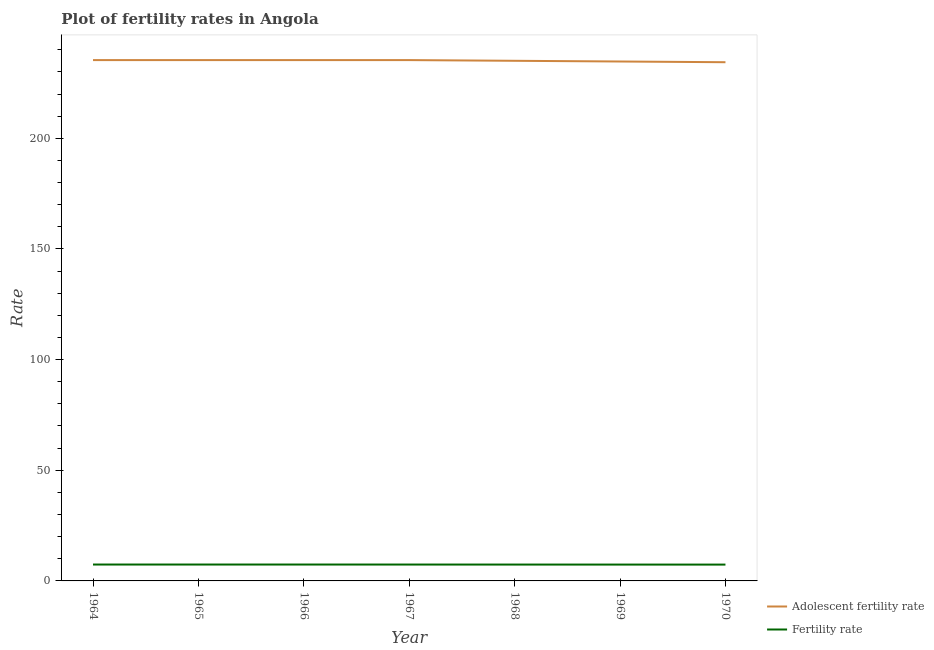Does the line corresponding to fertility rate intersect with the line corresponding to adolescent fertility rate?
Your answer should be very brief. No. Is the number of lines equal to the number of legend labels?
Your response must be concise. Yes. What is the adolescent fertility rate in 1966?
Give a very brief answer. 235.32. Across all years, what is the maximum fertility rate?
Ensure brevity in your answer.  7.41. Across all years, what is the minimum adolescent fertility rate?
Your response must be concise. 234.37. In which year was the adolescent fertility rate maximum?
Ensure brevity in your answer.  1964. What is the total fertility rate in the graph?
Make the answer very short. 51.77. What is the difference between the adolescent fertility rate in 1967 and that in 1968?
Make the answer very short. 0.32. What is the difference between the fertility rate in 1968 and the adolescent fertility rate in 1970?
Your answer should be very brief. -226.97. What is the average adolescent fertility rate per year?
Give a very brief answer. 235.05. In the year 1967, what is the difference between the adolescent fertility rate and fertility rate?
Give a very brief answer. 227.92. In how many years, is the fertility rate greater than 120?
Provide a short and direct response. 0. What is the ratio of the fertility rate in 1964 to that in 1965?
Provide a short and direct response. 1. What is the difference between the highest and the second highest fertility rate?
Make the answer very short. 0. What is the difference between the highest and the lowest fertility rate?
Ensure brevity in your answer.  0.03. Is the fertility rate strictly greater than the adolescent fertility rate over the years?
Make the answer very short. No. How many years are there in the graph?
Offer a terse response. 7. What is the difference between two consecutive major ticks on the Y-axis?
Your response must be concise. 50. Does the graph contain any zero values?
Keep it short and to the point. No. How many legend labels are there?
Your response must be concise. 2. What is the title of the graph?
Ensure brevity in your answer.  Plot of fertility rates in Angola. What is the label or title of the Y-axis?
Your response must be concise. Rate. What is the Rate in Adolescent fertility rate in 1964?
Ensure brevity in your answer.  235.32. What is the Rate of Fertility rate in 1964?
Your answer should be very brief. 7.41. What is the Rate in Adolescent fertility rate in 1965?
Offer a very short reply. 235.32. What is the Rate of Fertility rate in 1965?
Your answer should be very brief. 7.41. What is the Rate of Adolescent fertility rate in 1966?
Your answer should be very brief. 235.32. What is the Rate in Fertility rate in 1966?
Provide a succinct answer. 7.41. What is the Rate of Adolescent fertility rate in 1967?
Give a very brief answer. 235.32. What is the Rate of Fertility rate in 1967?
Offer a very short reply. 7.4. What is the Rate in Adolescent fertility rate in 1968?
Give a very brief answer. 235. What is the Rate of Fertility rate in 1968?
Offer a very short reply. 7.39. What is the Rate in Adolescent fertility rate in 1969?
Offer a terse response. 234.68. What is the Rate in Fertility rate in 1969?
Give a very brief answer. 7.38. What is the Rate of Adolescent fertility rate in 1970?
Your answer should be compact. 234.37. What is the Rate in Fertility rate in 1970?
Provide a short and direct response. 7.38. Across all years, what is the maximum Rate in Adolescent fertility rate?
Your answer should be very brief. 235.32. Across all years, what is the maximum Rate in Fertility rate?
Offer a terse response. 7.41. Across all years, what is the minimum Rate in Adolescent fertility rate?
Keep it short and to the point. 234.37. Across all years, what is the minimum Rate of Fertility rate?
Provide a succinct answer. 7.38. What is the total Rate in Adolescent fertility rate in the graph?
Provide a succinct answer. 1645.33. What is the total Rate in Fertility rate in the graph?
Make the answer very short. 51.77. What is the difference between the Rate in Adolescent fertility rate in 1964 and that in 1965?
Give a very brief answer. 0. What is the difference between the Rate in Fertility rate in 1964 and that in 1965?
Your answer should be compact. -0. What is the difference between the Rate in Fertility rate in 1964 and that in 1967?
Your answer should be compact. 0.01. What is the difference between the Rate of Adolescent fertility rate in 1964 and that in 1968?
Give a very brief answer. 0.32. What is the difference between the Rate in Fertility rate in 1964 and that in 1968?
Provide a short and direct response. 0.01. What is the difference between the Rate in Adolescent fertility rate in 1964 and that in 1969?
Your answer should be very brief. 0.64. What is the difference between the Rate of Fertility rate in 1964 and that in 1969?
Make the answer very short. 0.02. What is the difference between the Rate of Adolescent fertility rate in 1964 and that in 1970?
Your response must be concise. 0.95. What is the difference between the Rate in Fertility rate in 1964 and that in 1970?
Keep it short and to the point. 0.03. What is the difference between the Rate in Adolescent fertility rate in 1965 and that in 1966?
Make the answer very short. 0. What is the difference between the Rate in Fertility rate in 1965 and that in 1966?
Offer a very short reply. 0. What is the difference between the Rate of Adolescent fertility rate in 1965 and that in 1967?
Offer a very short reply. 0. What is the difference between the Rate in Fertility rate in 1965 and that in 1967?
Your response must be concise. 0.01. What is the difference between the Rate in Adolescent fertility rate in 1965 and that in 1968?
Ensure brevity in your answer.  0.32. What is the difference between the Rate in Fertility rate in 1965 and that in 1968?
Ensure brevity in your answer.  0.01. What is the difference between the Rate of Adolescent fertility rate in 1965 and that in 1969?
Offer a terse response. 0.64. What is the difference between the Rate of Fertility rate in 1965 and that in 1969?
Offer a terse response. 0.02. What is the difference between the Rate in Adolescent fertility rate in 1965 and that in 1970?
Your response must be concise. 0.95. What is the difference between the Rate in Fertility rate in 1965 and that in 1970?
Give a very brief answer. 0.03. What is the difference between the Rate in Fertility rate in 1966 and that in 1967?
Your response must be concise. 0.01. What is the difference between the Rate in Adolescent fertility rate in 1966 and that in 1968?
Your response must be concise. 0.32. What is the difference between the Rate of Fertility rate in 1966 and that in 1968?
Your answer should be very brief. 0.01. What is the difference between the Rate in Adolescent fertility rate in 1966 and that in 1969?
Your response must be concise. 0.64. What is the difference between the Rate in Fertility rate in 1966 and that in 1969?
Provide a succinct answer. 0.02. What is the difference between the Rate of Adolescent fertility rate in 1966 and that in 1970?
Your answer should be compact. 0.95. What is the difference between the Rate of Fertility rate in 1966 and that in 1970?
Offer a terse response. 0.03. What is the difference between the Rate in Adolescent fertility rate in 1967 and that in 1968?
Your answer should be very brief. 0.32. What is the difference between the Rate of Fertility rate in 1967 and that in 1968?
Make the answer very short. 0.01. What is the difference between the Rate of Adolescent fertility rate in 1967 and that in 1969?
Your response must be concise. 0.64. What is the difference between the Rate of Fertility rate in 1967 and that in 1969?
Keep it short and to the point. 0.02. What is the difference between the Rate of Adolescent fertility rate in 1967 and that in 1970?
Give a very brief answer. 0.95. What is the difference between the Rate of Fertility rate in 1967 and that in 1970?
Offer a terse response. 0.03. What is the difference between the Rate in Adolescent fertility rate in 1968 and that in 1969?
Offer a very short reply. 0.32. What is the difference between the Rate in Fertility rate in 1968 and that in 1969?
Give a very brief answer. 0.01. What is the difference between the Rate of Adolescent fertility rate in 1968 and that in 1970?
Your answer should be compact. 0.64. What is the difference between the Rate of Fertility rate in 1968 and that in 1970?
Provide a short and direct response. 0.02. What is the difference between the Rate of Adolescent fertility rate in 1969 and that in 1970?
Offer a terse response. 0.32. What is the difference between the Rate in Fertility rate in 1969 and that in 1970?
Provide a succinct answer. 0.01. What is the difference between the Rate in Adolescent fertility rate in 1964 and the Rate in Fertility rate in 1965?
Give a very brief answer. 227.91. What is the difference between the Rate of Adolescent fertility rate in 1964 and the Rate of Fertility rate in 1966?
Offer a very short reply. 227.91. What is the difference between the Rate in Adolescent fertility rate in 1964 and the Rate in Fertility rate in 1967?
Provide a short and direct response. 227.92. What is the difference between the Rate in Adolescent fertility rate in 1964 and the Rate in Fertility rate in 1968?
Ensure brevity in your answer.  227.93. What is the difference between the Rate in Adolescent fertility rate in 1964 and the Rate in Fertility rate in 1969?
Make the answer very short. 227.94. What is the difference between the Rate in Adolescent fertility rate in 1964 and the Rate in Fertility rate in 1970?
Offer a terse response. 227.94. What is the difference between the Rate of Adolescent fertility rate in 1965 and the Rate of Fertility rate in 1966?
Provide a succinct answer. 227.91. What is the difference between the Rate in Adolescent fertility rate in 1965 and the Rate in Fertility rate in 1967?
Offer a very short reply. 227.92. What is the difference between the Rate of Adolescent fertility rate in 1965 and the Rate of Fertility rate in 1968?
Your answer should be compact. 227.93. What is the difference between the Rate in Adolescent fertility rate in 1965 and the Rate in Fertility rate in 1969?
Your response must be concise. 227.94. What is the difference between the Rate in Adolescent fertility rate in 1965 and the Rate in Fertility rate in 1970?
Your answer should be very brief. 227.94. What is the difference between the Rate of Adolescent fertility rate in 1966 and the Rate of Fertility rate in 1967?
Ensure brevity in your answer.  227.92. What is the difference between the Rate of Adolescent fertility rate in 1966 and the Rate of Fertility rate in 1968?
Offer a very short reply. 227.93. What is the difference between the Rate of Adolescent fertility rate in 1966 and the Rate of Fertility rate in 1969?
Provide a short and direct response. 227.94. What is the difference between the Rate of Adolescent fertility rate in 1966 and the Rate of Fertility rate in 1970?
Provide a short and direct response. 227.94. What is the difference between the Rate in Adolescent fertility rate in 1967 and the Rate in Fertility rate in 1968?
Your answer should be compact. 227.93. What is the difference between the Rate in Adolescent fertility rate in 1967 and the Rate in Fertility rate in 1969?
Ensure brevity in your answer.  227.94. What is the difference between the Rate of Adolescent fertility rate in 1967 and the Rate of Fertility rate in 1970?
Your answer should be very brief. 227.94. What is the difference between the Rate of Adolescent fertility rate in 1968 and the Rate of Fertility rate in 1969?
Your answer should be compact. 227.62. What is the difference between the Rate of Adolescent fertility rate in 1968 and the Rate of Fertility rate in 1970?
Provide a succinct answer. 227.63. What is the difference between the Rate of Adolescent fertility rate in 1969 and the Rate of Fertility rate in 1970?
Your answer should be very brief. 227.31. What is the average Rate in Adolescent fertility rate per year?
Your answer should be compact. 235.05. What is the average Rate of Fertility rate per year?
Offer a terse response. 7.4. In the year 1964, what is the difference between the Rate of Adolescent fertility rate and Rate of Fertility rate?
Provide a short and direct response. 227.91. In the year 1965, what is the difference between the Rate of Adolescent fertility rate and Rate of Fertility rate?
Your answer should be very brief. 227.91. In the year 1966, what is the difference between the Rate of Adolescent fertility rate and Rate of Fertility rate?
Offer a very short reply. 227.91. In the year 1967, what is the difference between the Rate in Adolescent fertility rate and Rate in Fertility rate?
Your response must be concise. 227.92. In the year 1968, what is the difference between the Rate in Adolescent fertility rate and Rate in Fertility rate?
Offer a very short reply. 227.61. In the year 1969, what is the difference between the Rate in Adolescent fertility rate and Rate in Fertility rate?
Ensure brevity in your answer.  227.3. In the year 1970, what is the difference between the Rate in Adolescent fertility rate and Rate in Fertility rate?
Ensure brevity in your answer.  226.99. What is the ratio of the Rate of Adolescent fertility rate in 1964 to that in 1965?
Provide a short and direct response. 1. What is the ratio of the Rate in Fertility rate in 1964 to that in 1965?
Your response must be concise. 1. What is the ratio of the Rate of Adolescent fertility rate in 1964 to that in 1966?
Make the answer very short. 1. What is the ratio of the Rate in Adolescent fertility rate in 1964 to that in 1968?
Your response must be concise. 1. What is the ratio of the Rate of Fertility rate in 1964 to that in 1968?
Your answer should be compact. 1. What is the ratio of the Rate in Adolescent fertility rate in 1964 to that in 1969?
Offer a very short reply. 1. What is the ratio of the Rate of Fertility rate in 1964 to that in 1969?
Provide a short and direct response. 1. What is the ratio of the Rate of Fertility rate in 1965 to that in 1966?
Keep it short and to the point. 1. What is the ratio of the Rate of Adolescent fertility rate in 1965 to that in 1967?
Provide a succinct answer. 1. What is the ratio of the Rate in Adolescent fertility rate in 1965 to that in 1968?
Ensure brevity in your answer.  1. What is the ratio of the Rate in Adolescent fertility rate in 1965 to that in 1969?
Your response must be concise. 1. What is the ratio of the Rate of Fertility rate in 1965 to that in 1969?
Give a very brief answer. 1. What is the ratio of the Rate in Adolescent fertility rate in 1965 to that in 1970?
Your answer should be very brief. 1. What is the ratio of the Rate of Fertility rate in 1965 to that in 1970?
Provide a succinct answer. 1. What is the ratio of the Rate in Adolescent fertility rate in 1966 to that in 1967?
Your answer should be very brief. 1. What is the ratio of the Rate of Fertility rate in 1966 to that in 1968?
Provide a short and direct response. 1. What is the ratio of the Rate of Adolescent fertility rate in 1967 to that in 1968?
Your answer should be compact. 1. What is the ratio of the Rate in Fertility rate in 1967 to that in 1968?
Provide a short and direct response. 1. What is the ratio of the Rate in Fertility rate in 1967 to that in 1969?
Your answer should be very brief. 1. What is the ratio of the Rate of Adolescent fertility rate in 1967 to that in 1970?
Provide a short and direct response. 1. What is the ratio of the Rate of Fertility rate in 1967 to that in 1970?
Keep it short and to the point. 1. What is the ratio of the Rate in Adolescent fertility rate in 1968 to that in 1969?
Make the answer very short. 1. What is the ratio of the Rate in Fertility rate in 1968 to that in 1969?
Provide a succinct answer. 1. What is the ratio of the Rate in Adolescent fertility rate in 1968 to that in 1970?
Make the answer very short. 1. What is the ratio of the Rate in Fertility rate in 1968 to that in 1970?
Your answer should be compact. 1. What is the difference between the highest and the second highest Rate in Adolescent fertility rate?
Your response must be concise. 0. What is the difference between the highest and the second highest Rate of Fertility rate?
Your answer should be very brief. 0. What is the difference between the highest and the lowest Rate in Adolescent fertility rate?
Offer a terse response. 0.95. What is the difference between the highest and the lowest Rate in Fertility rate?
Your answer should be compact. 0.03. 